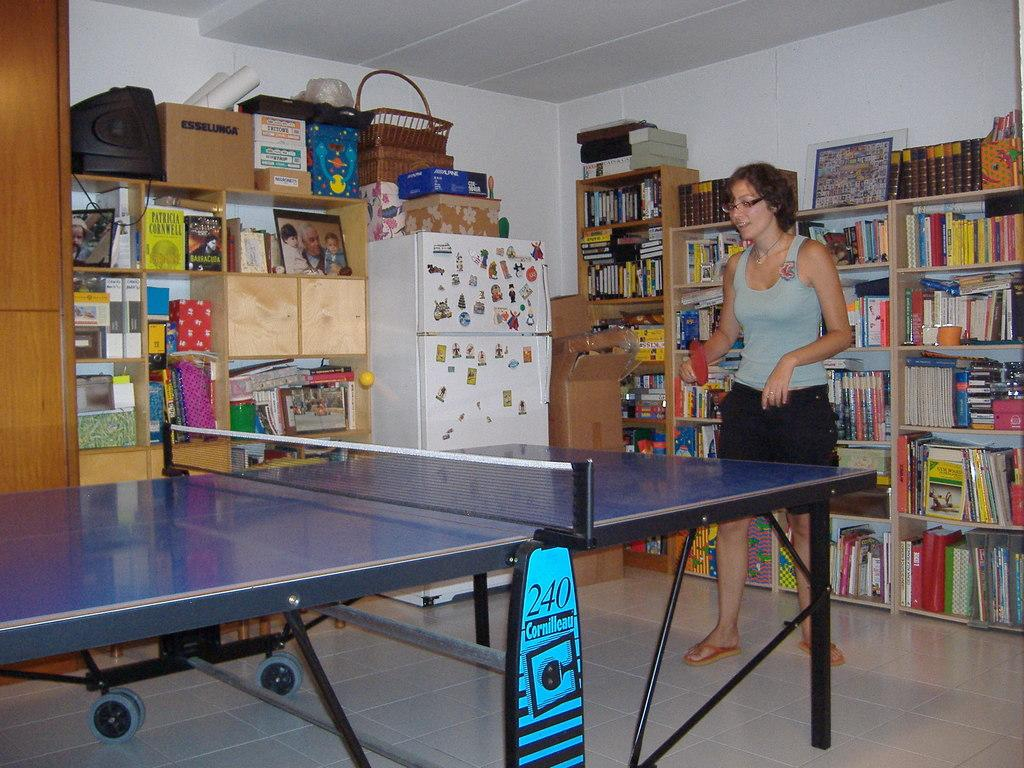What can be seen in the image that is used for storage? There is a shelf in the image that is used for storage. What is stored on the shelf? The shelf contains many books. What activity is the woman in the image engaged in? The woman is playing table tennis. What else can be seen on the shelf besides books? There are various items on top of the shelf. Can you tell me how many tigers are present in the image? There are no tigers present in the image. What type of silver item can be seen on the shelf? There is no silver item visible on the shelf in the image. 